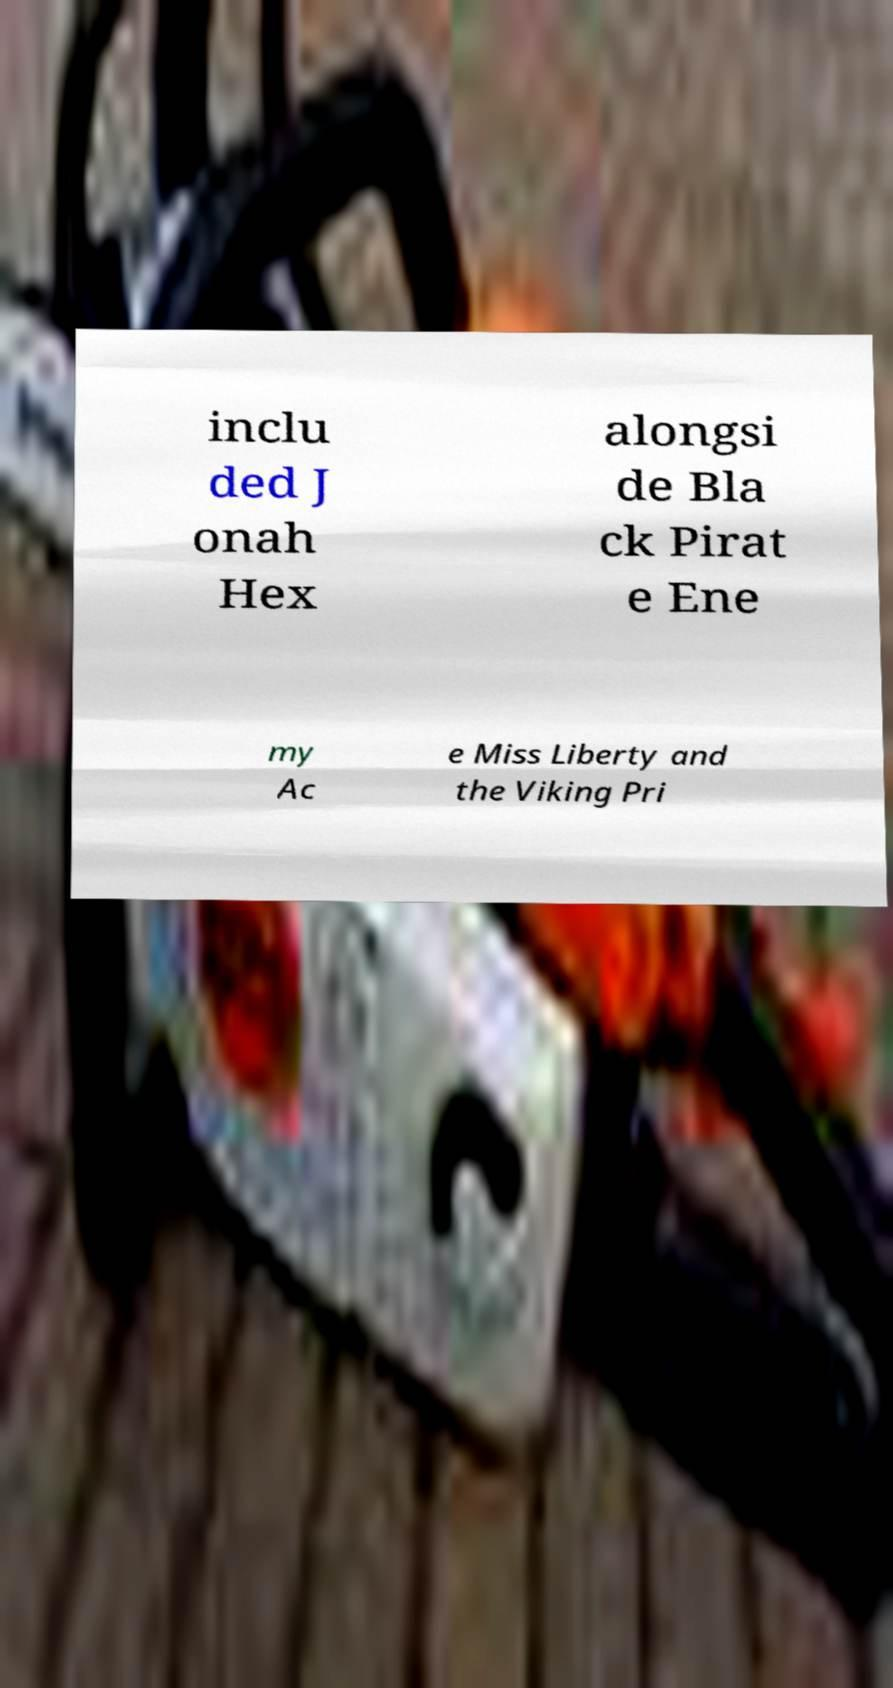Please read and relay the text visible in this image. What does it say? inclu ded J onah Hex alongsi de Bla ck Pirat e Ene my Ac e Miss Liberty and the Viking Pri 